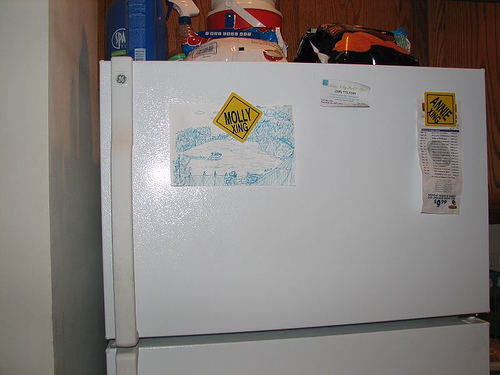Please identify all text content in this image. MOLLY KING ANNIE KING KING SPA 9 